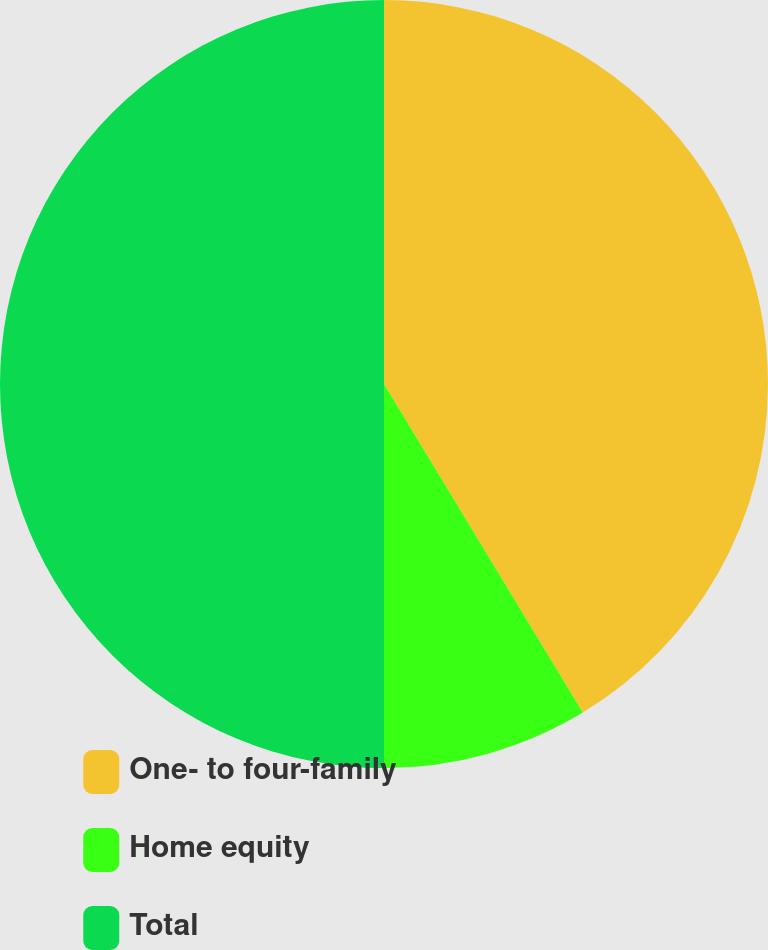Convert chart. <chart><loc_0><loc_0><loc_500><loc_500><pie_chart><fcel>One- to four-family<fcel>Home equity<fcel>Total<nl><fcel>41.34%<fcel>8.66%<fcel>50.0%<nl></chart> 